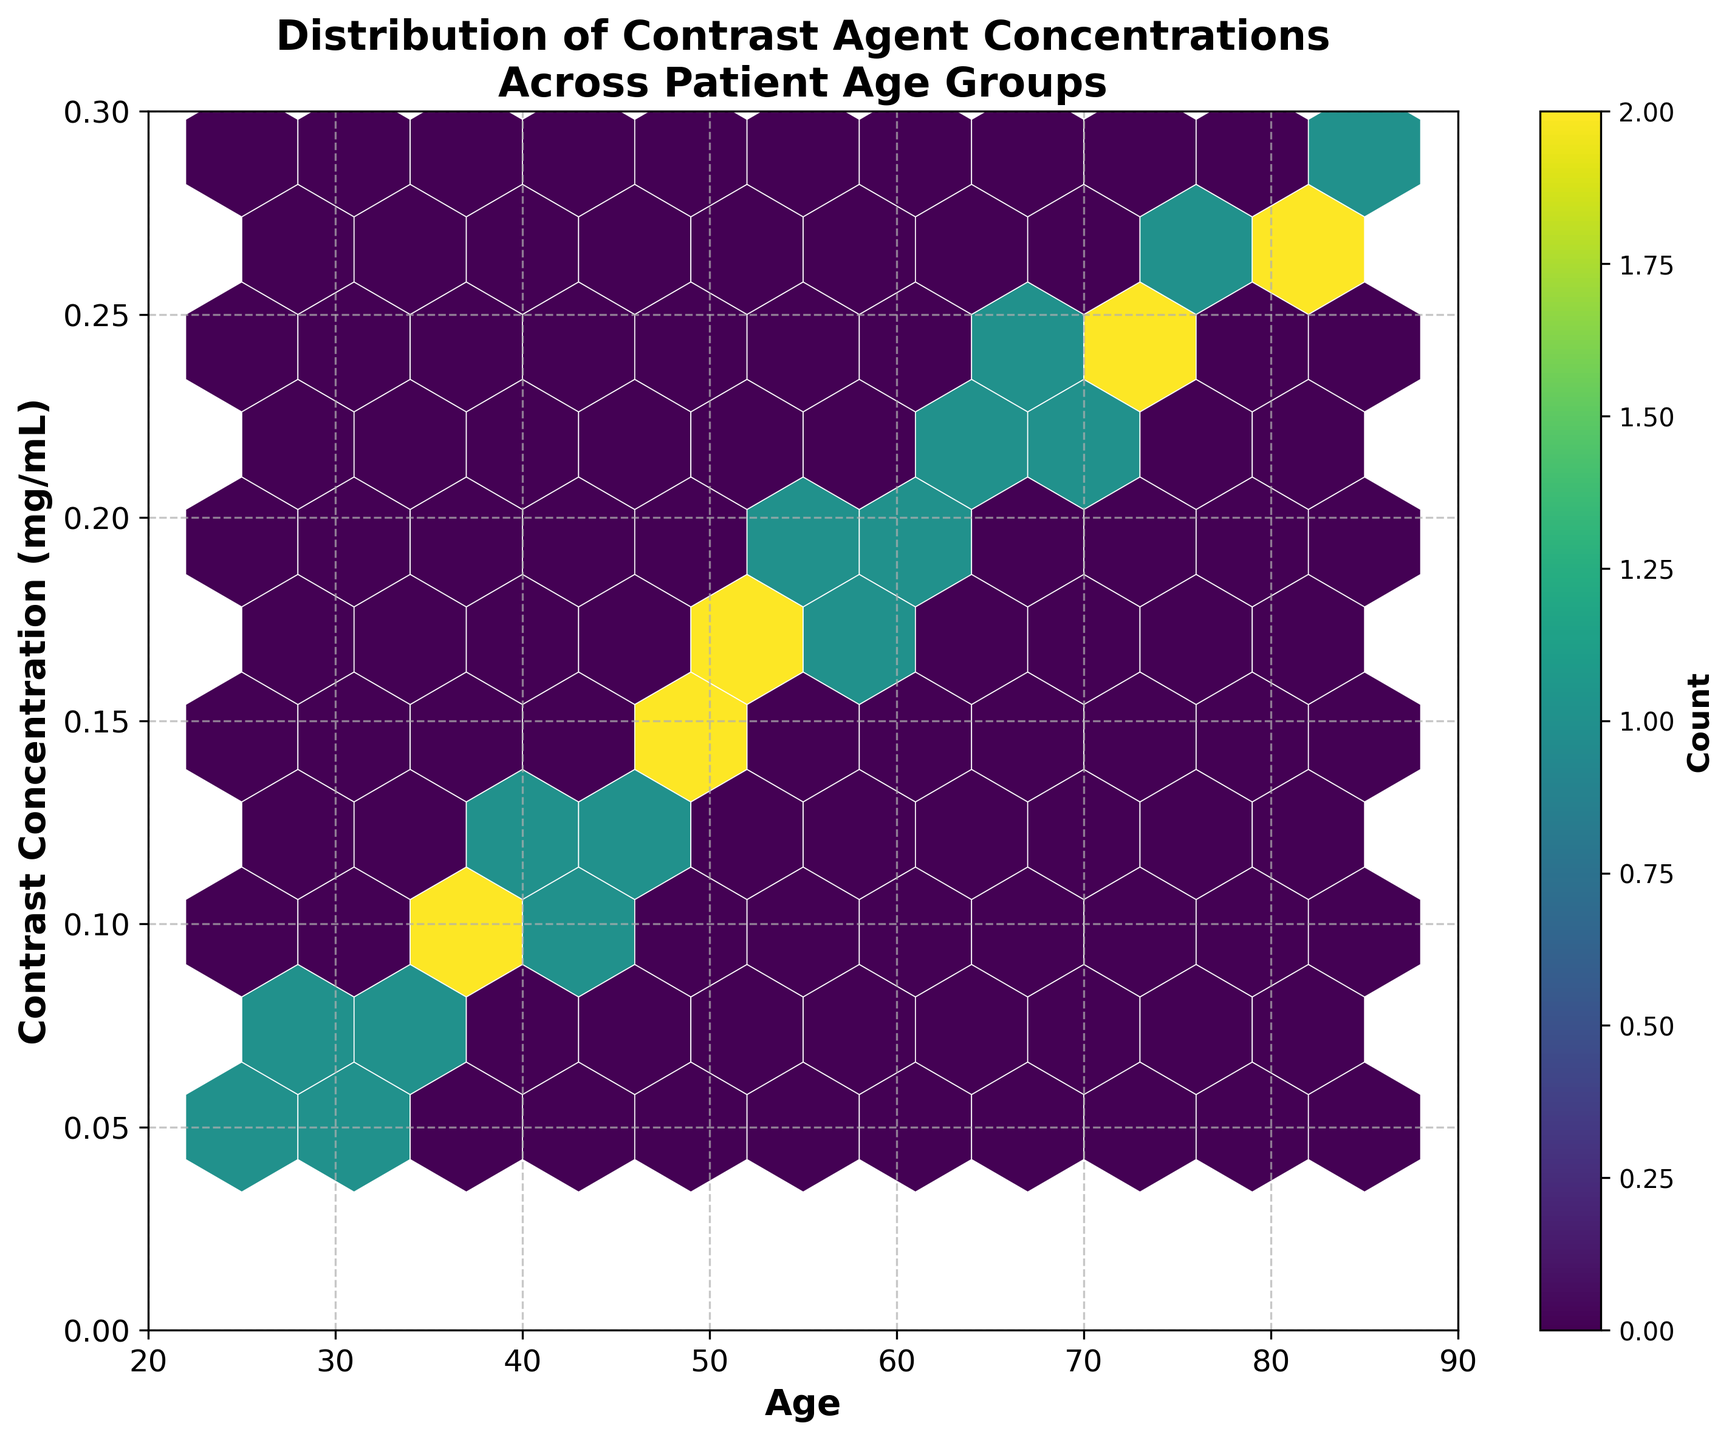What is the title of the plot? The title is usually placed at the top of the plot and describes what the plot is about. Here, it states "Distribution of Contrast Agent Concentrations Across Patient Age Groups".
Answer: Distribution of Contrast Agent Concentrations Across Patient Age Groups What are the labels of the x-axis and y-axis? The x-axis label is found horizontally below the x-axis, and the y-axis label is found vertically beside the y-axis. They indicate the variables being plotted.
Answer: Age; Contrast Concentration (mg/mL) What color map is used for the hexbin plot? The color map determines the color scheme used in the plot, which represents the density of data points. Here, "viridis" is used, which transitions from dark blue (low density) to yellow (high density).
Answer: viridis What does the color bar represent? A color bar provides a scale that indicates how the colors in the plot map to data values. In this figure, it shows the count of data points within each hexbin.
Answer: Count How does the distribution of data points change with age? Observing the hexbin plot, there seems to be a trend where the density and concentration of contrast agent increases with age. High-density areas shift upwards as age increases.
Answer: Increases with age Does the plot show a higher density of contrast agent concentrations for older age groups? By examining the color intensity on the plot, we see that older age groups (e.g., 60-85) have more regions with higher density (yellow) compared to younger age groups (e.g., 25-45).
Answer: Yes What is the range of ages displayed on the x-axis? The x-axis range can be determined by looking at the limits set on the plot. Here, it spans from 20 to 90 years.
Answer: 20 to 90 What is the range of contrast concentrations shown on the y-axis? The y-axis range can be found by identifying the limits set on the plot. In this case, it ranges from 0 to 0.3 mg/mL.
Answer: 0 to 0.3 mg/mL Which age group shows the highest contrast agent concentration based on the plot? The highest concentration is observed at the upper limit of the plot, around the age of 85 in the hexbin with the darkest color towards the top.
Answer: Around age 85 How many grid cells are used in the hexbin plot? The gridsize determines the number of hexagonal cells along the x-axis. Here, it's specified as 10, indicating a coarser grid with fewer larger cells.
Answer: 10 